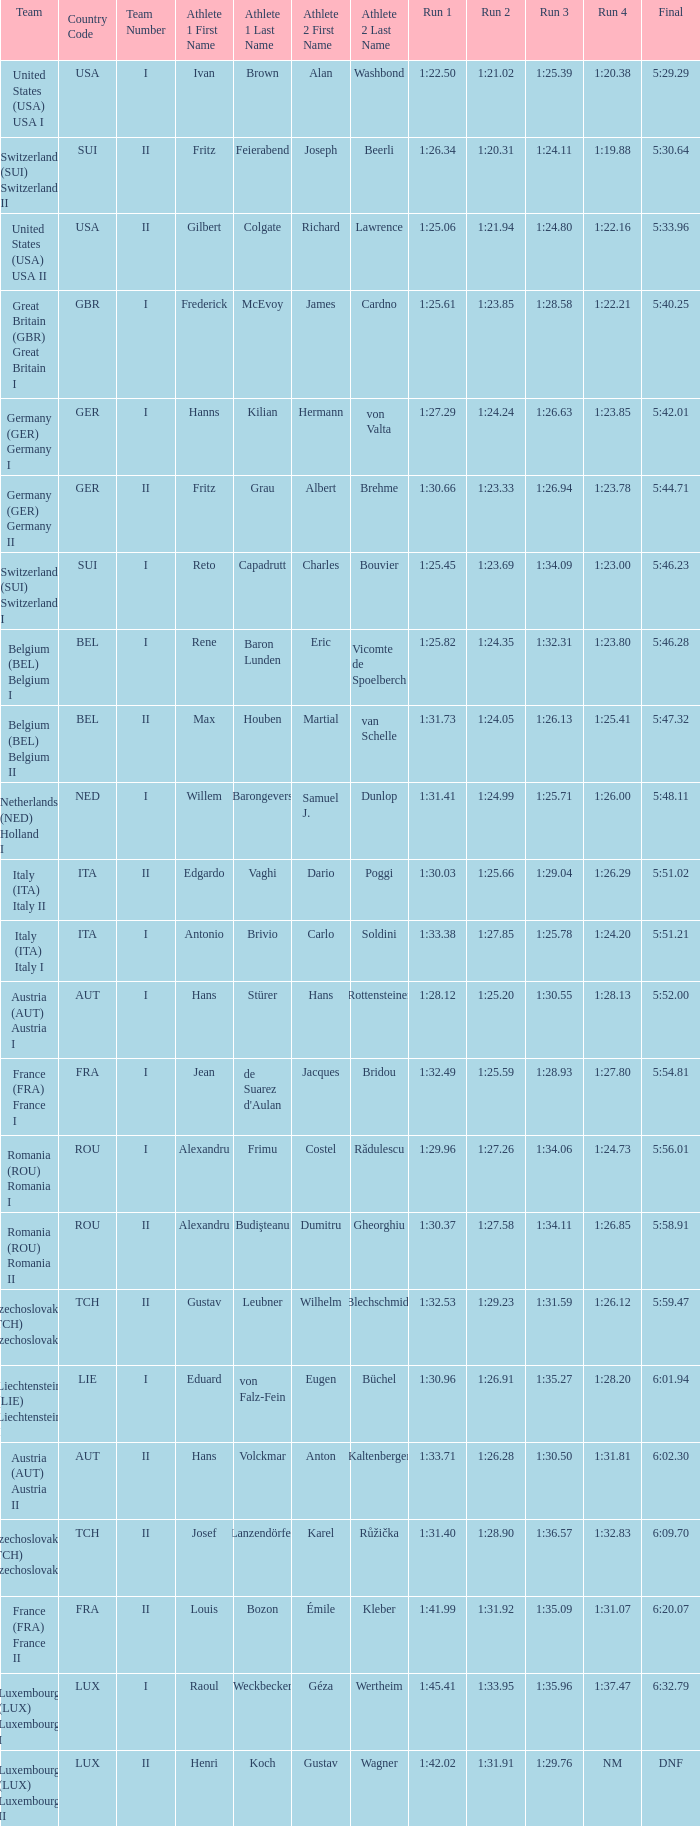Which Final has a Run 2 of 1:27.58? 5:58.91. Give me the full table as a dictionary. {'header': ['Team', 'Country Code', 'Team Number', 'Athlete 1 First Name', 'Athlete 1 Last Name', 'Athlete 2 First Name', 'Athlete 2 Last Name', 'Run 1', 'Run 2', 'Run 3', 'Run 4', 'Final'], 'rows': [['United States (USA) USA I', 'USA', 'I', 'Ivan', 'Brown', 'Alan', 'Washbond', '1:22.50', '1:21.02', '1:25.39', '1:20.38', '5:29.29'], ['Switzerland (SUI) Switzerland II', 'SUI', 'II', 'Fritz', 'Feierabend', 'Joseph', 'Beerli', '1:26.34', '1:20.31', '1:24.11', '1:19.88', '5:30.64'], ['United States (USA) USA II', 'USA', 'II', 'Gilbert', 'Colgate', 'Richard', 'Lawrence', '1:25.06', '1:21.94', '1:24.80', '1:22.16', '5:33.96'], ['Great Britain (GBR) Great Britain I', 'GBR', 'I', 'Frederick', 'McEvoy', 'James', 'Cardno', '1:25.61', '1:23.85', '1:28.58', '1:22.21', '5:40.25'], ['Germany (GER) Germany I', 'GER', 'I', 'Hanns', 'Kilian', 'Hermann', 'von Valta', '1:27.29', '1:24.24', '1:26.63', '1:23.85', '5:42.01'], ['Germany (GER) Germany II', 'GER', 'II', 'Fritz', 'Grau', 'Albert', 'Brehme', '1:30.66', '1:23.33', '1:26.94', '1:23.78', '5:44.71'], ['Switzerland (SUI) Switzerland I', 'SUI', 'I', 'Reto', 'Capadrutt', 'Charles', 'Bouvier', '1:25.45', '1:23.69', '1:34.09', '1:23.00', '5:46.23'], ['Belgium (BEL) Belgium I', 'BEL', 'I', 'Rene', 'Baron Lunden', 'Eric', 'Vicomte de Spoelberch', '1:25.82', '1:24.35', '1:32.31', '1:23.80', '5:46.28'], ['Belgium (BEL) Belgium II', 'BEL', 'II', 'Max', 'Houben', 'Martial', 'van Schelle', '1:31.73', '1:24.05', '1:26.13', '1:25.41', '5:47.32'], ['Netherlands (NED) Holland I', 'NED', 'I', 'Willem', 'Barongevers', 'Samuel J.', 'Dunlop', '1:31.41', '1:24.99', '1:25.71', '1:26.00', '5:48.11'], ['Italy (ITA) Italy II', 'ITA', 'II', 'Edgardo', 'Vaghi', 'Dario', 'Poggi', '1:30.03', '1:25.66', '1:29.04', '1:26.29', '5:51.02'], ['Italy (ITA) Italy I', 'ITA', 'I', 'Antonio', 'Brivio', 'Carlo', 'Soldini', '1:33.38', '1:27.85', '1:25.78', '1:24.20', '5:51.21'], ['Austria (AUT) Austria I', 'AUT', 'I', 'Hans', 'Stürer', 'Hans', 'Rottensteiner', '1:28.12', '1:25.20', '1:30.55', '1:28.13', '5:52.00'], ['France (FRA) France I', 'FRA', 'I', 'Jean', "de Suarez d'Aulan", 'Jacques', 'Bridou', '1:32.49', '1:25.59', '1:28.93', '1:27.80', '5:54.81'], ['Romania (ROU) Romania I', 'ROU', 'I', 'Alexandru', 'Frimu', 'Costel', 'Rădulescu', '1:29.96', '1:27.26', '1:34.06', '1:24.73', '5:56.01'], ['Romania (ROU) Romania II', 'ROU', 'II', 'Alexandru', 'Budişteanu', 'Dumitru', 'Gheorghiu', '1:30.37', '1:27.58', '1:34.11', '1:26.85', '5:58.91'], ['Czechoslovakia (TCH) Czechoslovakia II', 'TCH', 'II', 'Gustav', 'Leubner', 'Wilhelm', 'Blechschmidt', '1:32.53', '1:29.23', '1:31.59', '1:26.12', '5:59.47'], ['Liechtenstein (LIE) Liechtenstein I', 'LIE', 'I', 'Eduard', 'von Falz-Fein', 'Eugen', 'Büchel', '1:30.96', '1:26.91', '1:35.27', '1:28.20', '6:01.94'], ['Austria (AUT) Austria II', 'AUT', 'II', 'Hans', 'Volckmar', 'Anton', 'Kaltenberger', '1:33.71', '1:26.28', '1:30.50', '1:31.81', '6:02.30'], ['Czechoslovakia (TCH) Czechoslovakia II', 'TCH', 'II', 'Josef', 'Lanzendörfer', 'Karel', 'Růžička', '1:31.40', '1:28.90', '1:36.57', '1:32.83', '6:09.70'], ['France (FRA) France II', 'FRA', 'II', 'Louis', 'Bozon', 'Émile', 'Kleber', '1:41.99', '1:31.92', '1:35.09', '1:31.07', '6:20.07'], ['Luxembourg (LUX) Luxembourg I', 'LUX', 'I', 'Raoul', 'Weckbecker', 'Géza', 'Wertheim', '1:45.41', '1:33.95', '1:35.96', '1:37.47', '6:32.79'], ['Luxembourg (LUX) Luxembourg II', 'LUX', 'II', 'Henri', 'Koch', 'Gustav', 'Wagner', '1:42.02', '1:31.91', '1:29.76', 'NM', 'DNF']]} 